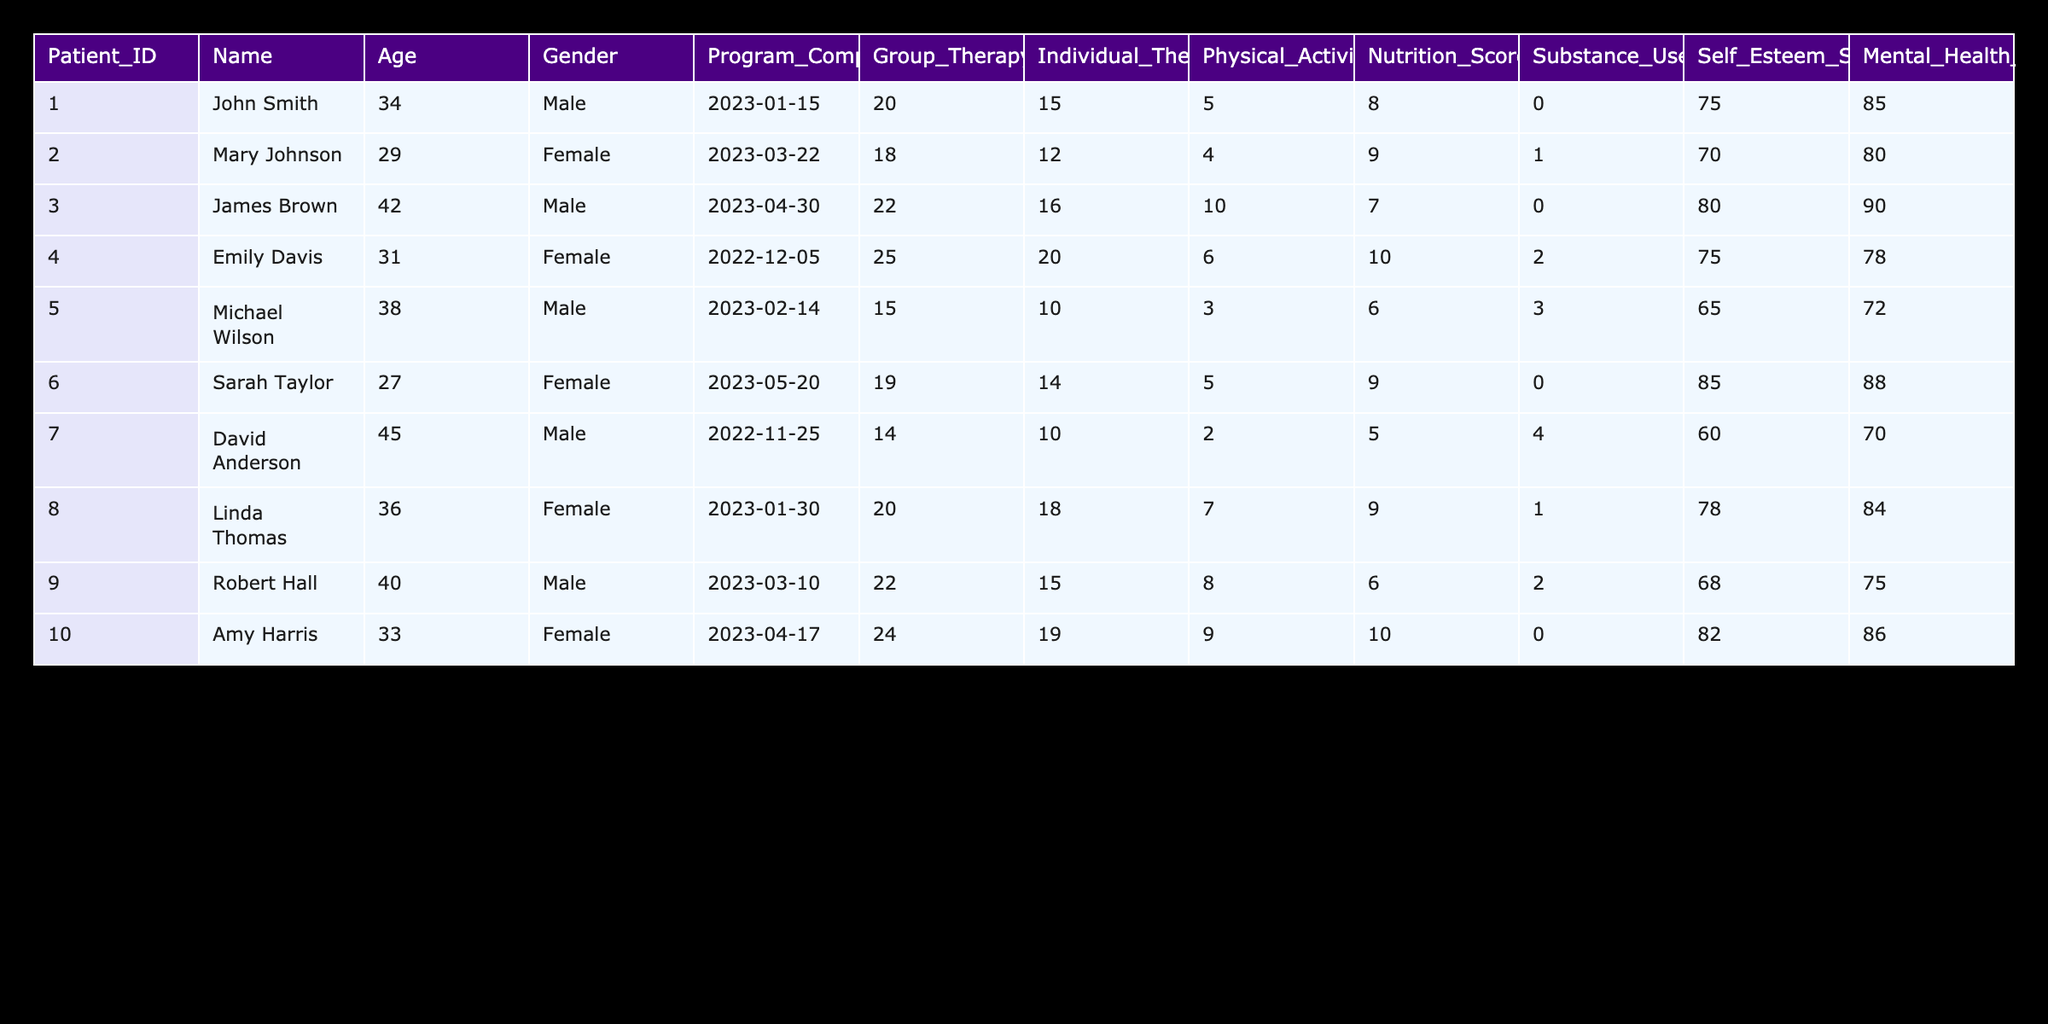What is the Substance Use Frequency of Sarah Taylor? To find the Substance Use Frequency for Sarah Taylor, locate her row in the table. She is listed as Patient_ID 006, and her Substance Use Frequency is noted as 0.
Answer: 0 What is the highest Self Esteem Score among all patients? First, review the Self Esteem Scores in the table: 75, 70, 80, 75, 65, 85, 60, 78, 68, 82. The highest score from these values is 85, which belongs to Sarah Taylor.
Answer: 85 How many Group Therapy Sessions did Emily Davis attend? Emily Davis is listed as Patient_ID 004. In her row, the Group Therapy Sessions Attended is stated as 25.
Answer: 25 What is the average number of physical activity hours per week across all patients? To find the average, sum the Physical Activity Hours: 5 + 4 + 10 + 6 + 3 + 5 + 2 + 7 + 8 + 9 = 59. Then divide that by the number of patients, which is 10. So the average is 59 / 10 = 5.9.
Answer: 5.9 Is the Nutrition Score of Robert Hall greater than 7? The Nutrition Score for Robert Hall, Patient_ID 009, is 6. Since 6 is not greater than 7, the answer is no.
Answer: No Which patient attended the least number of Individual Therapy Sessions? Review the Individual Therapy Sessions Attended column: 15, 12, 16, 20, 10, 14, 10, 18, 15, 19. The lowest number here is 10, attended by both Michael Wilson and David Anderson.
Answer: Michael Wilson and David Anderson What is the Mental Health Assessment Score of the oldest patient? The oldest patient in the table is David Anderson, who is 45 years old. His Mental Health Assessment Score is 70, as indicated in his row.
Answer: 70 Did any patients have a Substance Use Frequency of 1 or greater? Reviewing the Substance Use Frequency column: 0, 1, 0, 2, 3, 0, 4, 1, 2, 0. There are values equal to or greater than 1, which means yes, there were patients with such frequencies.
Answer: Yes What is the difference in Nutrition Scores between the patient with the highest score and the patient with the lowest score? The highest Nutrition Score is 10 (Emily Davis), and the lowest is 5 (David Anderson). The difference is 10 - 5 = 5.
Answer: 5 How many patients completed their rehabilitation programs before January 2023? The relevant completion dates for the patients are January 15, 2023, and earlier dates. Checking the table, Emily Davis (December 5, 2022) and David Anderson (November 25, 2022) completed their programs before January 2023. Thus, there are 2 patients.
Answer: 2 